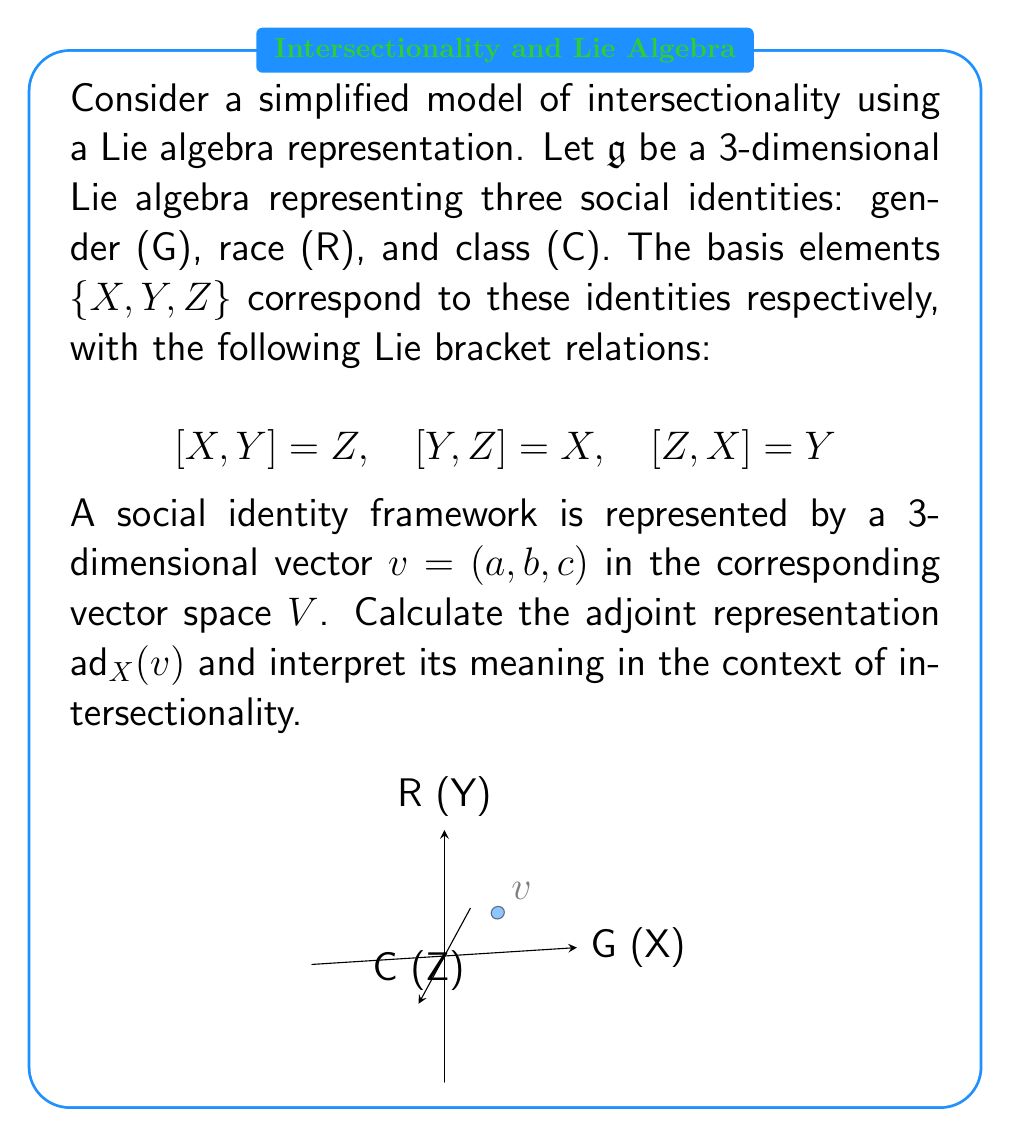Help me with this question. To solve this problem, we'll follow these steps:

1) The adjoint representation $\text{ad}_X$ is defined by $\text{ad}_X(Y) = [X,Y]$ for any Y in the Lie algebra.

2) For the given vector $v = (a, b, c)$, we need to calculate:
   $$\text{ad}_X(v) = \text{ad}_X(aX + bY + cZ)$$

3) Using the linearity of the Lie bracket:
   $$\text{ad}_X(v) = a\text{ad}_X(X) + b\text{ad}_X(Y) + c\text{ad}_X(Z)$$

4) Now, let's calculate each term:
   - $\text{ad}_X(X) = [X,X] = 0$ (Lie bracket is antisymmetric)
   - $\text{ad}_X(Y) = [X,Y] = Z$
   - $\text{ad}_X(Z) = [X,Z] = -Y$ (using $[Z,X] = Y$ and antisymmetry)

5) Substituting these results:
   $$\text{ad}_X(v) = a(0) + b(Z) + c(-Y) = (0, -c, b)$$

6) Interpretation in the context of intersectionality:
   - The adjoint representation $\text{ad}_X(v)$ shows how the gender identity (X) interacts with the overall social identity framework (v).
   - The result (0, -c, b) indicates that:
     a) Gender identity doesn't affect itself (0 coefficient for X)
     b) It has a positive interaction with race (b coefficient for Z)
     c) It has a negative interaction with class (-c coefficient for Y)
   - This representation captures the idea that different social identities are not independent but interact with each other, which is a key concept in intersectionality.
Answer: $\text{ad}_X(v) = (0, -c, b)$ 